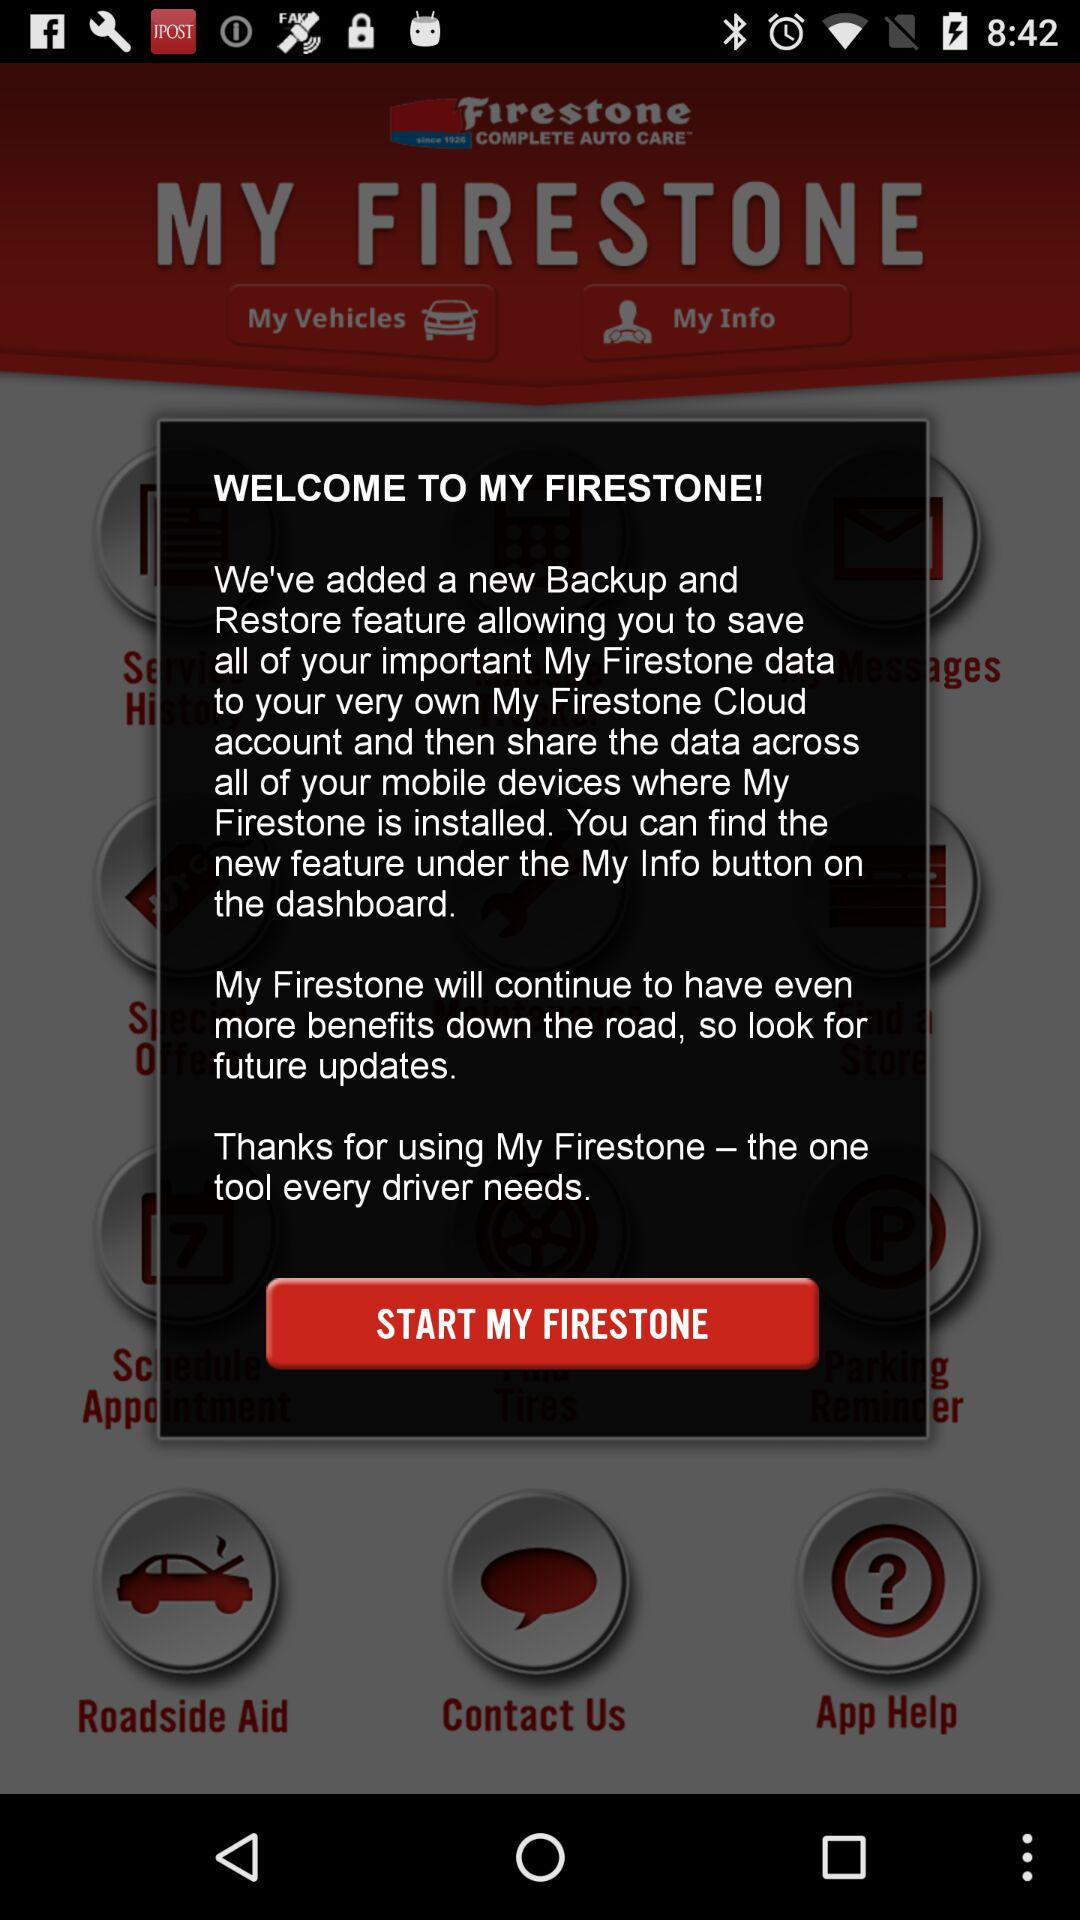What new features are added? The new feature added is "Backup and Restore". 